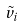<formula> <loc_0><loc_0><loc_500><loc_500>\tilde { v } _ { i }</formula> 